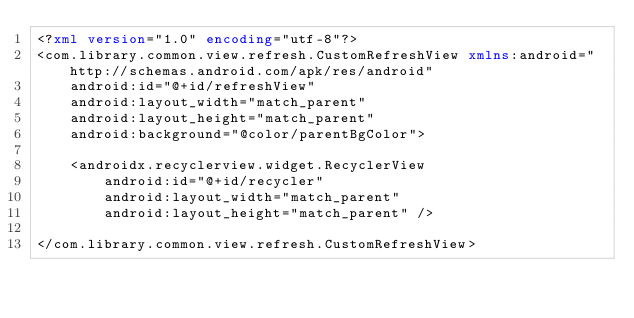<code> <loc_0><loc_0><loc_500><loc_500><_XML_><?xml version="1.0" encoding="utf-8"?>
<com.library.common.view.refresh.CustomRefreshView xmlns:android="http://schemas.android.com/apk/res/android"
    android:id="@+id/refreshView"
    android:layout_width="match_parent"
    android:layout_height="match_parent"
    android:background="@color/parentBgColor">

    <androidx.recyclerview.widget.RecyclerView
        android:id="@+id/recycler"
        android:layout_width="match_parent"
        android:layout_height="match_parent" />

</com.library.common.view.refresh.CustomRefreshView></code> 